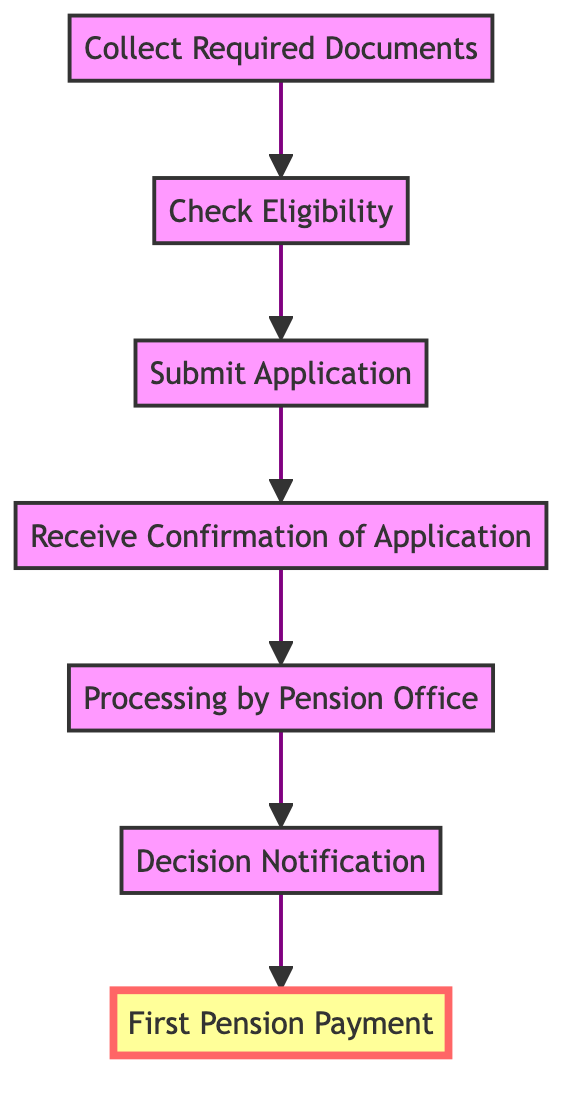What is the first step in the pension application process? The diagram shows the flow starting from the bottom, where the first step is to 'Collect Required Documents'. This is the foundational stage before proceeding further in the application process.
Answer: Collect Required Documents How many total steps are outlined in the diagram? By counting the nodes in the diagram, there are seven distinct steps depicted, illustrating the full process of applying for and receiving pension benefits.
Answer: 7 Which step follows 'Submit Application'? The flow shows that directly after 'Submit Application,' the next step is 'Receive Confirmation of Application'. So, this is the immediate next action in the process.
Answer: Receive Confirmation of Application What document is necessary to begin the process? The starting node indicates that to begin the process, one must 'Collect Required Documents.' This step is crucial as it lays the groundwork for the entire application.
Answer: Collect Required Documents What does the final step of the process involve? According to the diagram, the last step is 'First Pension Payment,' which signifies the culmination of all prior actions leading to actually receiving the pension funds.
Answer: First Pension Payment What is the relationship between 'Processing by Pension Office' and 'Decision Notification'? The flow indicates that 'Processing by Pension Office' leads to 'Decision Notification'. This means that after the application is reviewed, the next action is to inform the applicant of the decision made regarding their pension.
Answer: Processing by Pension Office leads to Decision Notification How many steps are there before receiving the first pension payment? The diagram clearly illustrates that there are six steps that occur prior to reaching the 'First Pension Payment' node, reflecting the progressive nature of the application process.
Answer: 6 What is the last action taken before the first pension payment? The diagram shows that the step just preceding 'First Pension Payment' is 'Decision Notification', emphasizing that a decision must be communicated before any payments are issued.
Answer: Decision Notification 